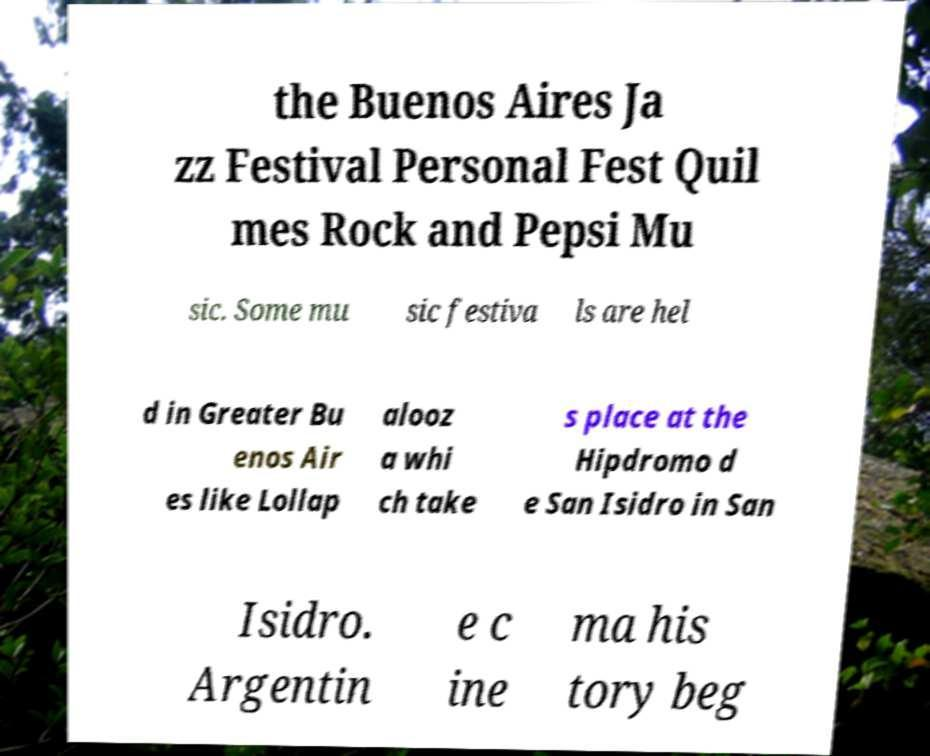Could you assist in decoding the text presented in this image and type it out clearly? the Buenos Aires Ja zz Festival Personal Fest Quil mes Rock and Pepsi Mu sic. Some mu sic festiva ls are hel d in Greater Bu enos Air es like Lollap alooz a whi ch take s place at the Hipdromo d e San Isidro in San Isidro. Argentin e c ine ma his tory beg 